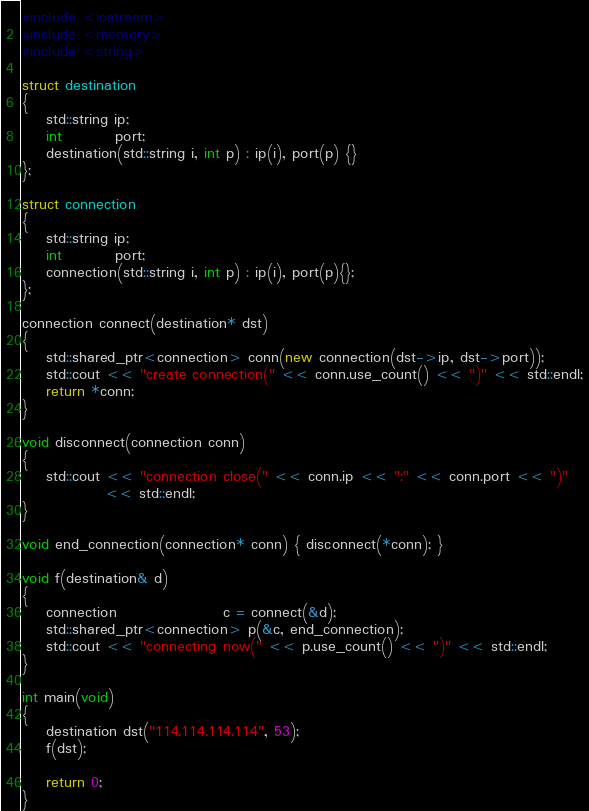Convert code to text. <code><loc_0><loc_0><loc_500><loc_500><_C++_>#include <iostream>
#include <memory>
#include <string>

struct destination
{
    std::string ip;
    int         port;
    destination(std::string i, int p) : ip(i), port(p) {}
};

struct connection
{
    std::string ip;
    int         port;
    connection(std::string i, int p) : ip(i), port(p){};
};

connection connect(destination* dst)
{
    std::shared_ptr<connection> conn(new connection(dst->ip, dst->port));
    std::cout << "create connection(" << conn.use_count() << ")" << std::endl;
    return *conn;
}

void disconnect(connection conn)
{
    std::cout << "connection close(" << conn.ip << ":" << conn.port << ")"
              << std::endl;
}

void end_connection(connection* conn) { disconnect(*conn); }

void f(destination& d)
{
    connection                  c = connect(&d);
    std::shared_ptr<connection> p(&c, end_connection);
    std::cout << "connecting now(" << p.use_count() << ")" << std::endl;
}

int main(void)
{
    destination dst("114.114.114.114", 53);
    f(dst);

    return 0;
}</code> 